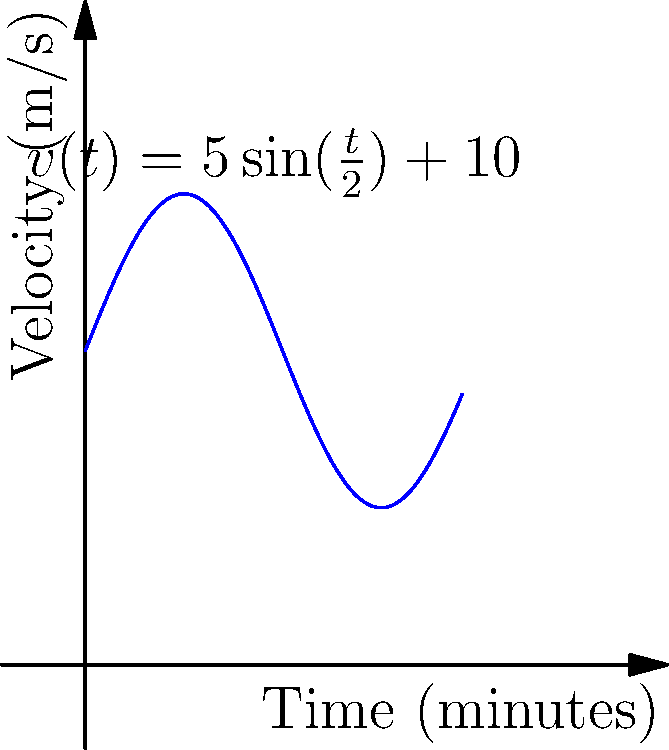During a crucial match between New Zealand and Fiji in the OFC Nations Cup, a New Zealand player's velocity (in meters per second) at time $t$ (in minutes) is given by the function $v(t) = 5\sin(\frac{t}{2}) + 10$ for $0 \leq t \leq 12$. Calculate the total distance covered by the player during this 12-minute period of the match. To find the total distance covered, we need to integrate the velocity function over the given time interval. Here's how we solve it:

1) The distance covered is given by the definite integral of velocity:
   $$\text{Distance} = \int_0^{12} v(t) dt = \int_0^{12} (5\sin(\frac{t}{2}) + 10) dt$$

2) Let's integrate this function:
   $$\int_0^{12} (5\sin(\frac{t}{2}) + 10) dt = [-10\cos(\frac{t}{2}) + 10t]_0^{12}$$

3) Evaluate the integral:
   $$= [-10\cos(6) + 120] - [-10\cos(0) + 0]$$
   $$= [-10\cos(6) + 120] - [-10 + 0]$$
   $$= -10\cos(6) + 120 + 10$$

4) Simplify:
   $$= -10\cos(6) + 130$$
   $$\approx 125.16$$

Therefore, the player covered approximately 125.16 meters during this 12-minute period.
Answer: 125.16 meters 